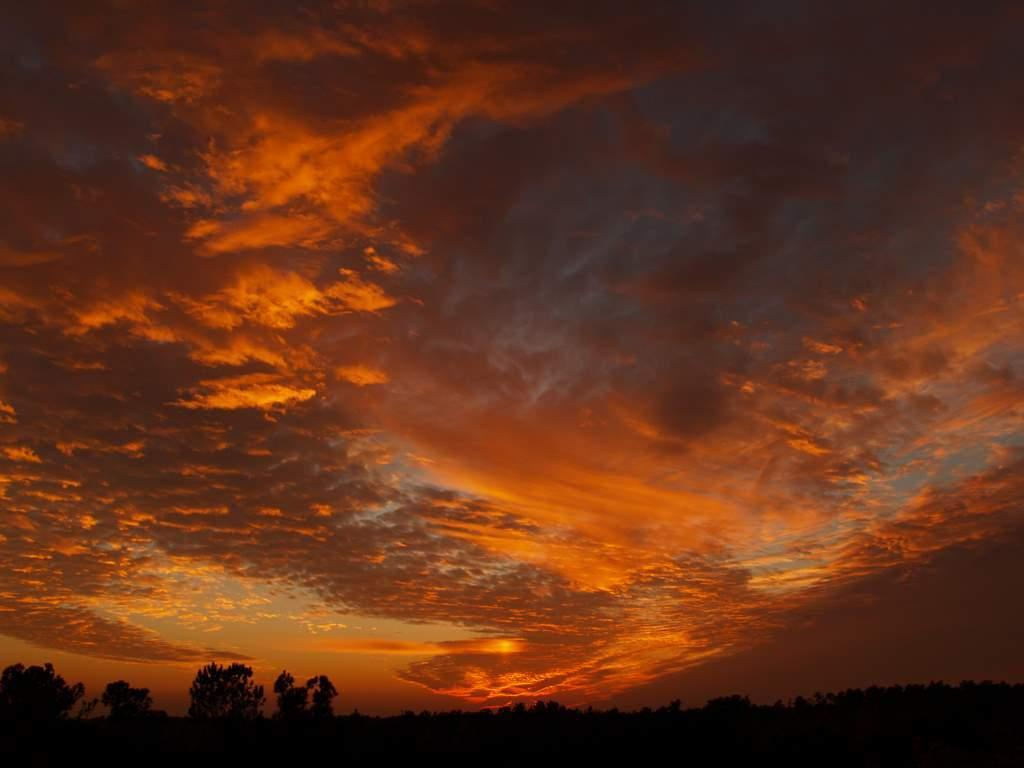What is the condition of the sky in the image? The sky in the image is cloudy. What type of vegetation can be seen at the bottom of the image? There are many trees visible at the bottom of the image. How many times does the person in the image sneeze? There is no person present in the image, so it is not possible to determine how many times they sneeze. What day of the week is depicted in the image? The image does not show a specific day of the week, so it cannot be determined from the image. 